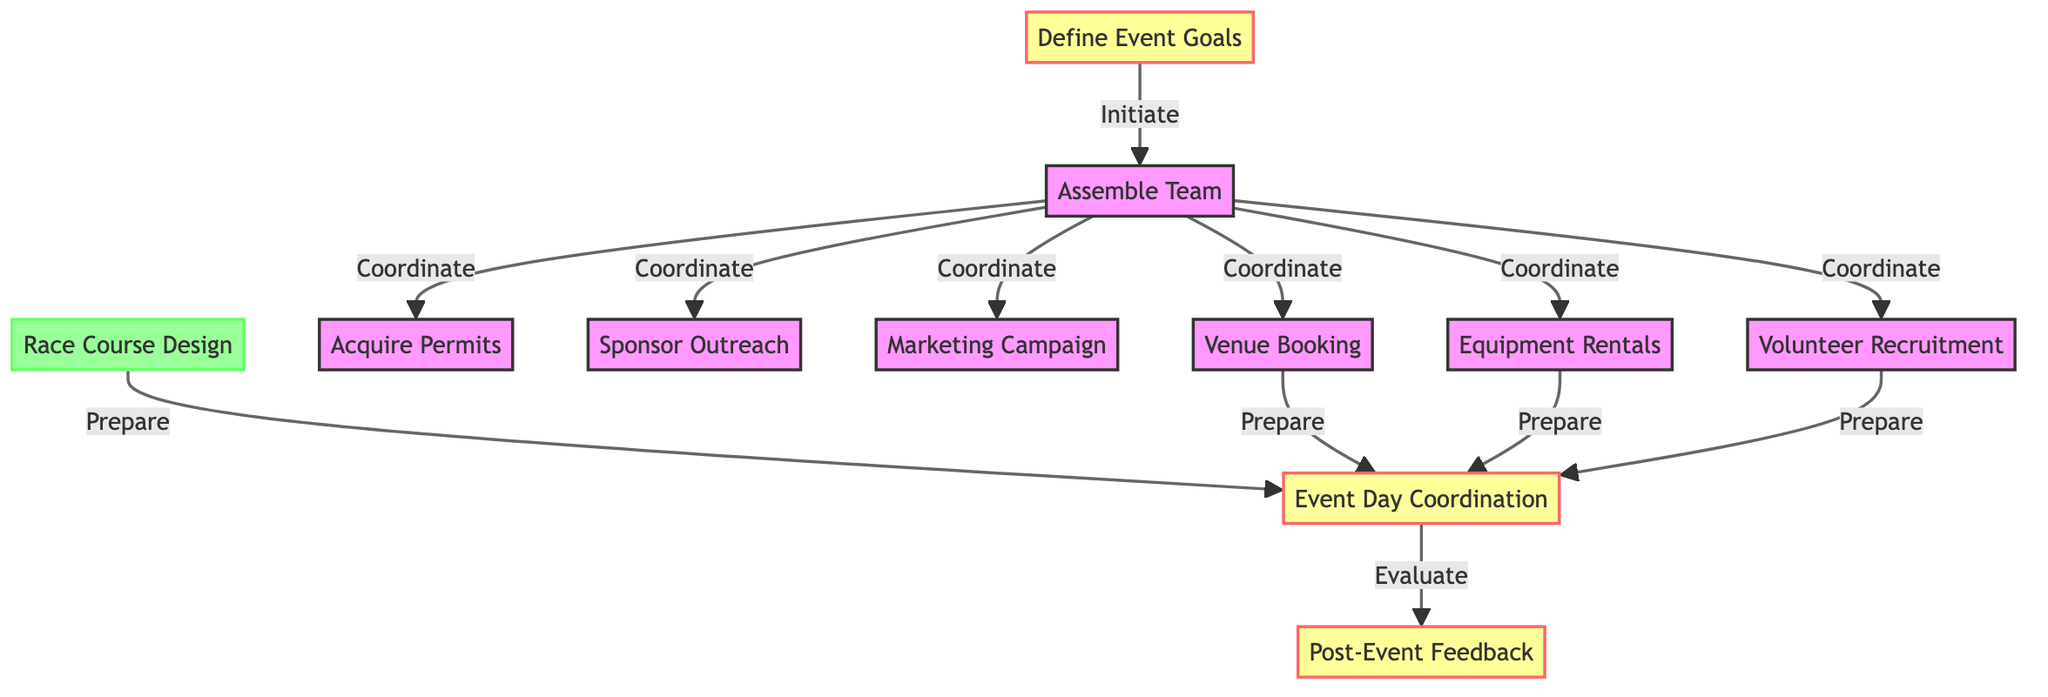What is the first task in the event planning timeline? The diagram shows that the first task is "Define Event Goals", which is the initial step in the sequence of events.
Answer: Define Event Goals How many team coordination tasks are there? By examining the connections from "Assemble Team", we can see that there are six coordination tasks that branch out to venue booking, permits, sponsor outreach, marketing campaign, equipment rentals, and volunteer recruitment.
Answer: 6 Which task leads to race day coordination? The diagram indicates that the tasks leading to "Event Day Coordination" include volunteer recruitment, equipment rentals, venue booking, and race course design. Race course design is one of the preparation tasks identified by the arrow leading to event day.
Answer: Race Course Design What is the last task in the timeline? The diagram clearly identifies "Post-Event Feedback" as the final task, which follows the completion of "Event Day Coordination".
Answer: Post-Event Feedback How many total tasks are displayed in the diagram? By counting all the tasks listed in the diagram, including those that connect to each other, we find that there are eleven tasks overall.
Answer: 11 What type of task is "Acquire Permits"? In the diagram, "Acquire Permits" is categorized as a standard task and does not fall under the categories of event or preparation tasks, so it is classified as part of the general tasks.
Answer: Standard Task Which task requires feedback evaluation? The diagram shows that "Event Day Coordination" directly leads to "Post-Event Feedback", meaning that feedback evaluation is specifically tied to this task.
Answer: Event Day Coordination How many preparation tasks are illustrated in the diagram? The diagram lists a single preparation task, which is "Race Course Design", clearly defined as a preparatory activity leading to event day coordination.
Answer: 1 